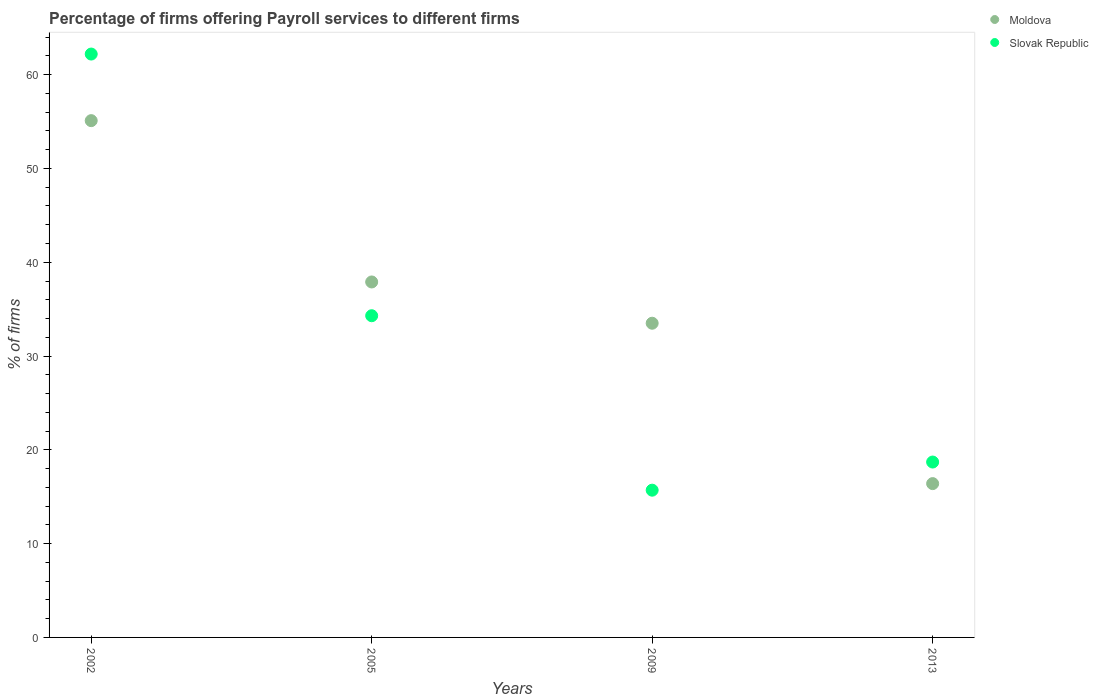How many different coloured dotlines are there?
Ensure brevity in your answer.  2. Is the number of dotlines equal to the number of legend labels?
Keep it short and to the point. Yes. What is the percentage of firms offering payroll services in Moldova in 2002?
Ensure brevity in your answer.  55.1. Across all years, what is the maximum percentage of firms offering payroll services in Moldova?
Provide a short and direct response. 55.1. What is the total percentage of firms offering payroll services in Slovak Republic in the graph?
Make the answer very short. 130.9. What is the difference between the percentage of firms offering payroll services in Slovak Republic in 2005 and that in 2009?
Provide a short and direct response. 18.6. What is the difference between the percentage of firms offering payroll services in Moldova in 2002 and the percentage of firms offering payroll services in Slovak Republic in 2013?
Your answer should be very brief. 36.4. What is the average percentage of firms offering payroll services in Moldova per year?
Your response must be concise. 35.73. In the year 2005, what is the difference between the percentage of firms offering payroll services in Slovak Republic and percentage of firms offering payroll services in Moldova?
Your answer should be compact. -3.6. What is the ratio of the percentage of firms offering payroll services in Slovak Republic in 2005 to that in 2013?
Give a very brief answer. 1.83. Is the percentage of firms offering payroll services in Moldova in 2002 less than that in 2009?
Offer a very short reply. No. What is the difference between the highest and the second highest percentage of firms offering payroll services in Moldova?
Your answer should be very brief. 17.2. What is the difference between the highest and the lowest percentage of firms offering payroll services in Moldova?
Offer a very short reply. 38.7. Is the sum of the percentage of firms offering payroll services in Moldova in 2002 and 2009 greater than the maximum percentage of firms offering payroll services in Slovak Republic across all years?
Give a very brief answer. Yes. Does the percentage of firms offering payroll services in Moldova monotonically increase over the years?
Your answer should be compact. No. Is the percentage of firms offering payroll services in Slovak Republic strictly less than the percentage of firms offering payroll services in Moldova over the years?
Offer a very short reply. No. How many dotlines are there?
Keep it short and to the point. 2. How many years are there in the graph?
Your response must be concise. 4. What is the difference between two consecutive major ticks on the Y-axis?
Your answer should be compact. 10. Are the values on the major ticks of Y-axis written in scientific E-notation?
Your answer should be compact. No. Does the graph contain grids?
Your response must be concise. No. What is the title of the graph?
Your answer should be very brief. Percentage of firms offering Payroll services to different firms. What is the label or title of the X-axis?
Ensure brevity in your answer.  Years. What is the label or title of the Y-axis?
Keep it short and to the point. % of firms. What is the % of firms of Moldova in 2002?
Give a very brief answer. 55.1. What is the % of firms in Slovak Republic in 2002?
Your answer should be compact. 62.2. What is the % of firms of Moldova in 2005?
Ensure brevity in your answer.  37.9. What is the % of firms in Slovak Republic in 2005?
Make the answer very short. 34.3. What is the % of firms in Moldova in 2009?
Ensure brevity in your answer.  33.5. What is the % of firms of Slovak Republic in 2009?
Your answer should be very brief. 15.7. What is the % of firms of Moldova in 2013?
Your answer should be compact. 16.4. What is the % of firms of Slovak Republic in 2013?
Ensure brevity in your answer.  18.7. Across all years, what is the maximum % of firms in Moldova?
Your response must be concise. 55.1. Across all years, what is the maximum % of firms in Slovak Republic?
Give a very brief answer. 62.2. Across all years, what is the minimum % of firms in Moldova?
Your response must be concise. 16.4. What is the total % of firms in Moldova in the graph?
Offer a terse response. 142.9. What is the total % of firms of Slovak Republic in the graph?
Your answer should be very brief. 130.9. What is the difference between the % of firms in Moldova in 2002 and that in 2005?
Your answer should be compact. 17.2. What is the difference between the % of firms in Slovak Republic in 2002 and that in 2005?
Provide a short and direct response. 27.9. What is the difference between the % of firms of Moldova in 2002 and that in 2009?
Your answer should be very brief. 21.6. What is the difference between the % of firms in Slovak Republic in 2002 and that in 2009?
Offer a terse response. 46.5. What is the difference between the % of firms in Moldova in 2002 and that in 2013?
Your answer should be compact. 38.7. What is the difference between the % of firms in Slovak Republic in 2002 and that in 2013?
Provide a short and direct response. 43.5. What is the difference between the % of firms of Moldova in 2005 and that in 2013?
Ensure brevity in your answer.  21.5. What is the difference between the % of firms of Slovak Republic in 2005 and that in 2013?
Give a very brief answer. 15.6. What is the difference between the % of firms in Moldova in 2009 and that in 2013?
Make the answer very short. 17.1. What is the difference between the % of firms in Moldova in 2002 and the % of firms in Slovak Republic in 2005?
Make the answer very short. 20.8. What is the difference between the % of firms in Moldova in 2002 and the % of firms in Slovak Republic in 2009?
Ensure brevity in your answer.  39.4. What is the difference between the % of firms of Moldova in 2002 and the % of firms of Slovak Republic in 2013?
Your answer should be compact. 36.4. What is the difference between the % of firms of Moldova in 2005 and the % of firms of Slovak Republic in 2009?
Provide a short and direct response. 22.2. What is the difference between the % of firms of Moldova in 2009 and the % of firms of Slovak Republic in 2013?
Provide a short and direct response. 14.8. What is the average % of firms of Moldova per year?
Offer a very short reply. 35.73. What is the average % of firms in Slovak Republic per year?
Make the answer very short. 32.73. In the year 2013, what is the difference between the % of firms in Moldova and % of firms in Slovak Republic?
Your answer should be very brief. -2.3. What is the ratio of the % of firms in Moldova in 2002 to that in 2005?
Provide a short and direct response. 1.45. What is the ratio of the % of firms in Slovak Republic in 2002 to that in 2005?
Offer a very short reply. 1.81. What is the ratio of the % of firms of Moldova in 2002 to that in 2009?
Provide a short and direct response. 1.64. What is the ratio of the % of firms in Slovak Republic in 2002 to that in 2009?
Your answer should be compact. 3.96. What is the ratio of the % of firms of Moldova in 2002 to that in 2013?
Your answer should be compact. 3.36. What is the ratio of the % of firms in Slovak Republic in 2002 to that in 2013?
Keep it short and to the point. 3.33. What is the ratio of the % of firms of Moldova in 2005 to that in 2009?
Ensure brevity in your answer.  1.13. What is the ratio of the % of firms in Slovak Republic in 2005 to that in 2009?
Your answer should be compact. 2.18. What is the ratio of the % of firms in Moldova in 2005 to that in 2013?
Give a very brief answer. 2.31. What is the ratio of the % of firms of Slovak Republic in 2005 to that in 2013?
Offer a very short reply. 1.83. What is the ratio of the % of firms of Moldova in 2009 to that in 2013?
Your answer should be compact. 2.04. What is the ratio of the % of firms in Slovak Republic in 2009 to that in 2013?
Provide a short and direct response. 0.84. What is the difference between the highest and the second highest % of firms of Slovak Republic?
Make the answer very short. 27.9. What is the difference between the highest and the lowest % of firms of Moldova?
Keep it short and to the point. 38.7. What is the difference between the highest and the lowest % of firms of Slovak Republic?
Provide a succinct answer. 46.5. 